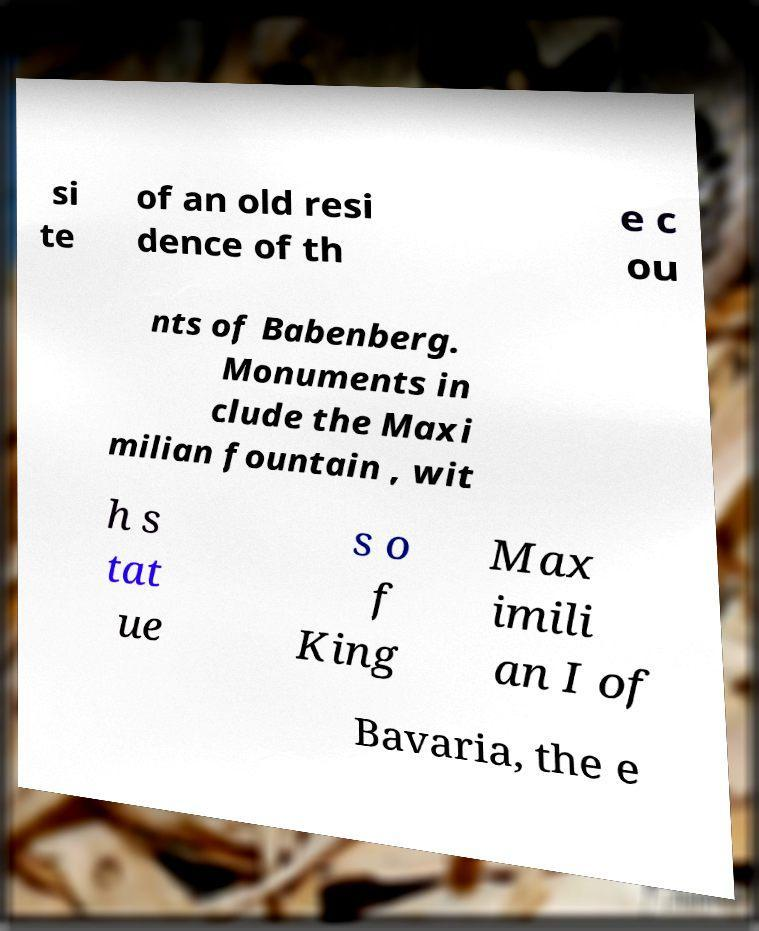Can you read and provide the text displayed in the image?This photo seems to have some interesting text. Can you extract and type it out for me? si te of an old resi dence of th e c ou nts of Babenberg. Monuments in clude the Maxi milian fountain , wit h s tat ue s o f King Max imili an I of Bavaria, the e 